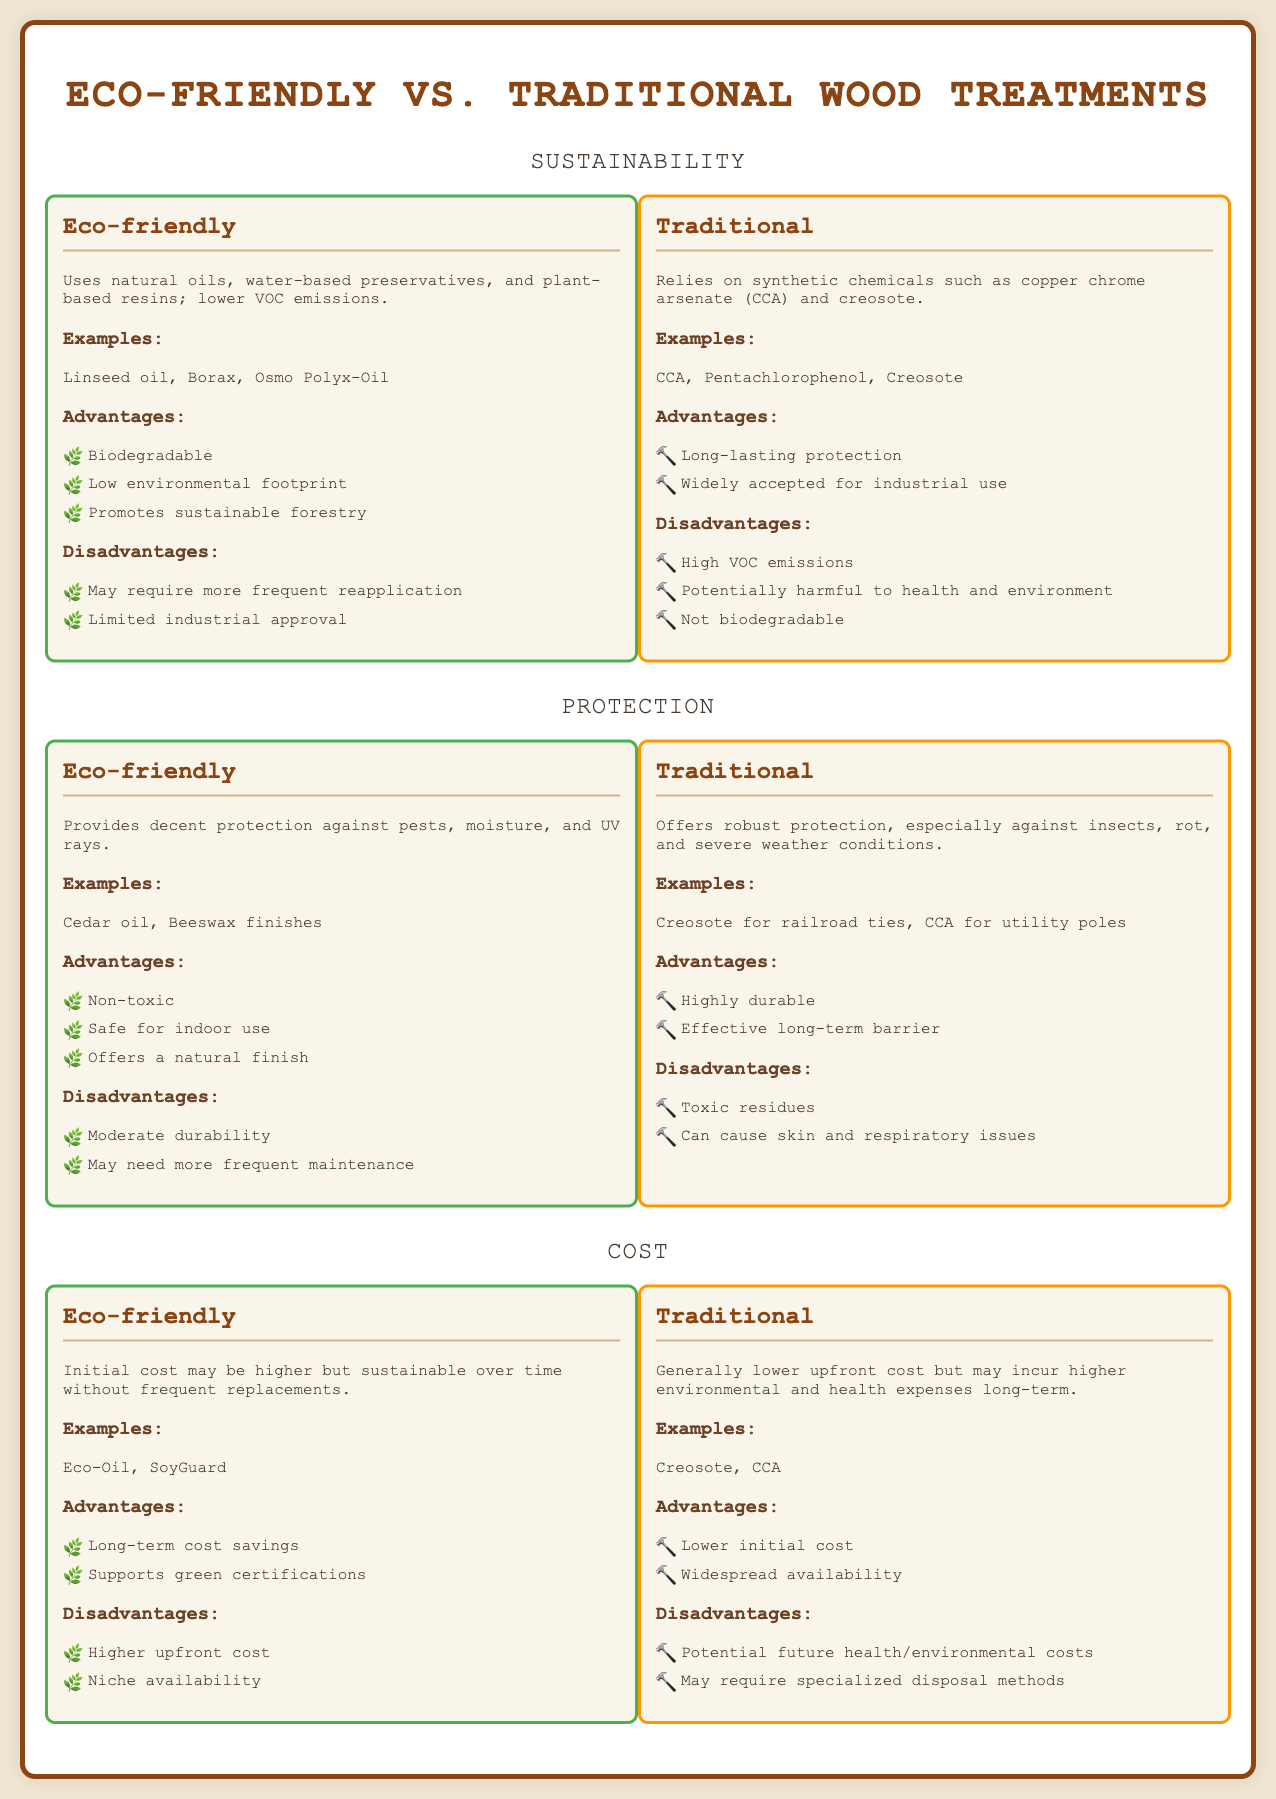What are the natural oils used in eco-friendly treatments? The document lists Linseed oil as one of the natural oils used in eco-friendly treatments.
Answer: Linseed oil What is a disadvantage of using eco-friendly wood treatments? The document states that one disadvantage is that eco-friendly treatments may require more frequent reapplication.
Answer: More frequent reapplication Which treatment is described as offering long-lasting protection? The document indicates that traditional treatments offer long-lasting protection.
Answer: Traditional What type of chemicals does traditional wood treatment rely on? The document specifies that traditional wood treatment relies on synthetic chemicals.
Answer: Synthetic chemicals What is a major advantage of eco-friendly wood treatments? The document mentions that eco-friendly treatments have a low environmental footprint as an advantage.
Answer: Low environmental footprint How does the initial cost of eco-friendly treatments compare to traditional ones? The document states that the initial cost of eco-friendly treatments may be higher than traditional ones.
Answer: Higher What is the key disadvantage of traditional wood treatments? The document highlights that traditional wood treatments can be potentially harmful to health and the environment.
Answer: Potentially harmful In terms of availability, which type of treatment is more niche? The document notes that eco-friendly wood treatments have niche availability.
Answer: Niche availability What type of certification do eco-friendly treatments support? The document points out that eco-friendly wood treatments support green certifications.
Answer: Green certifications 